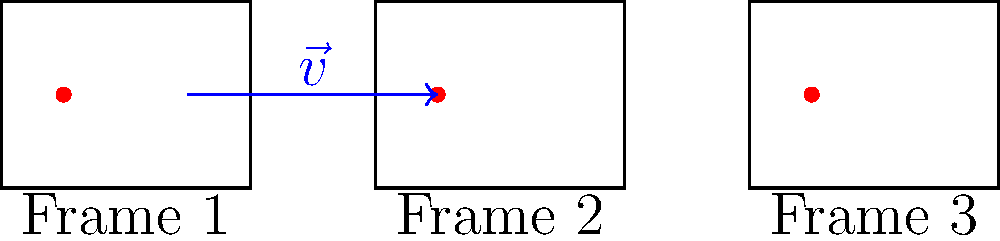In a storyboard sequence exploring character movement, a filmmaker uses translation to represent a character's position change across frames. Given the storyboard frames above, what is the translation vector $\vec{v}$ that moves the character from Frame 1 to Frame 2, and how would you express the character's position in Frame 3 using this vector? To solve this problem, we'll follow these steps:

1. Identify the translation vector $\vec{v}$:
   - The character moves from $(0.5, 0.75)$ in Frame 1 to $(3.5, 0.75)$ in Frame 2.
   - $\vec{v} = (3.5, 0.75) - (0.5, 0.75) = (3, 0)$

2. Express the character's position in Frame 3:
   - The character's position in Frame 1 is $(0.5, 0.75)$.
   - To reach Frame 3, we apply the translation vector twice.
   - Position in Frame 3 = Initial position + 2$\vec{v}$
   - $(0.5, 0.75) + 2(3, 0) = (0.5, 0.75) + (6, 0) = (6.5, 0.75)$

3. Verify the result:
   - The character's position in Frame 3 is indeed $(6.5, 0.75)$, which matches the diagram.

This translation technique in storyboarding is crucial for maintaining consistency in character movement across frames, an essential skill for aspiring film directors when planning complex scenes.
Answer: $\vec{v} = (3, 0)$; Frame 3 position: $(0.5, 0.75) + 2\vec{v} = (6.5, 0.75)$ 